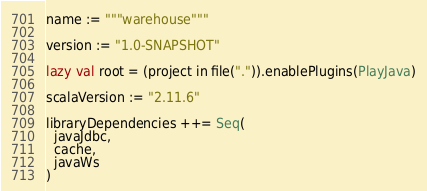<code> <loc_0><loc_0><loc_500><loc_500><_Scala_>name := """warehouse"""

version := "1.0-SNAPSHOT"

lazy val root = (project in file(".")).enablePlugins(PlayJava)

scalaVersion := "2.11.6"

libraryDependencies ++= Seq(
  javaJdbc,
  cache,
  javaWs
)

</code> 